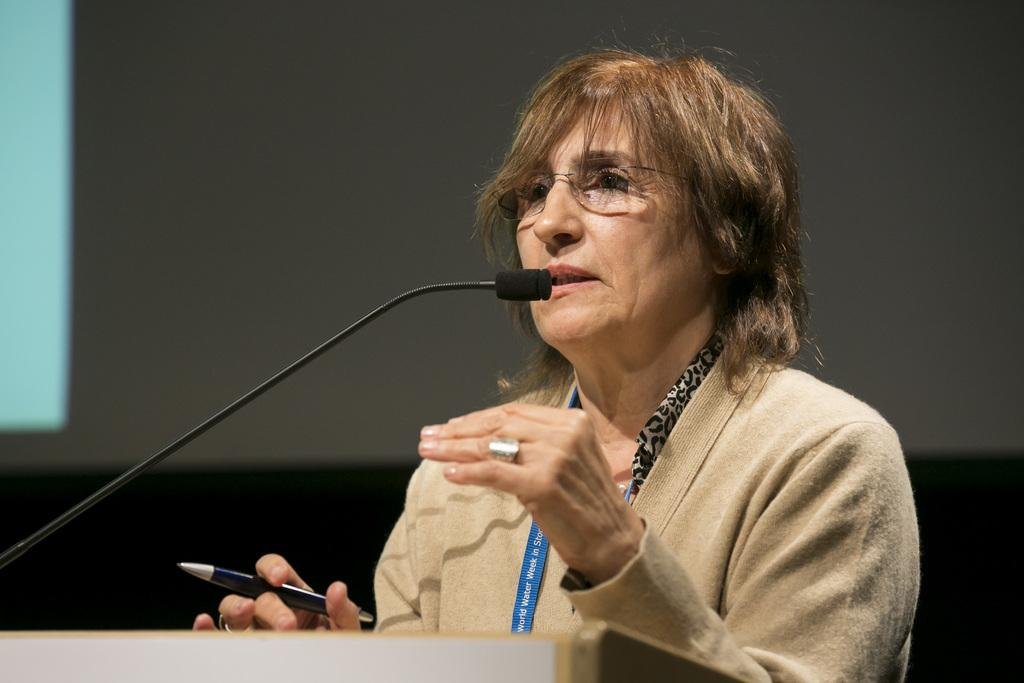Who is the main subject in the image? There is a woman in the image. What is the woman holding in her hand? The woman is holding a pen in her hand. What can be seen behind the woman in the image? The woman is standing in front of a podium. What is on the podium? There is a microphone on the podium. How would you describe the lighting in the image? The background of the image is dark. How many people are wearing masks in the image? There are no people wearing masks in the image, as it only features a woman standing in front of a podium. What type of attack is being carried out in the image? There is no attack depicted in the image; it shows a woman standing in front of a podium with a microphone. 